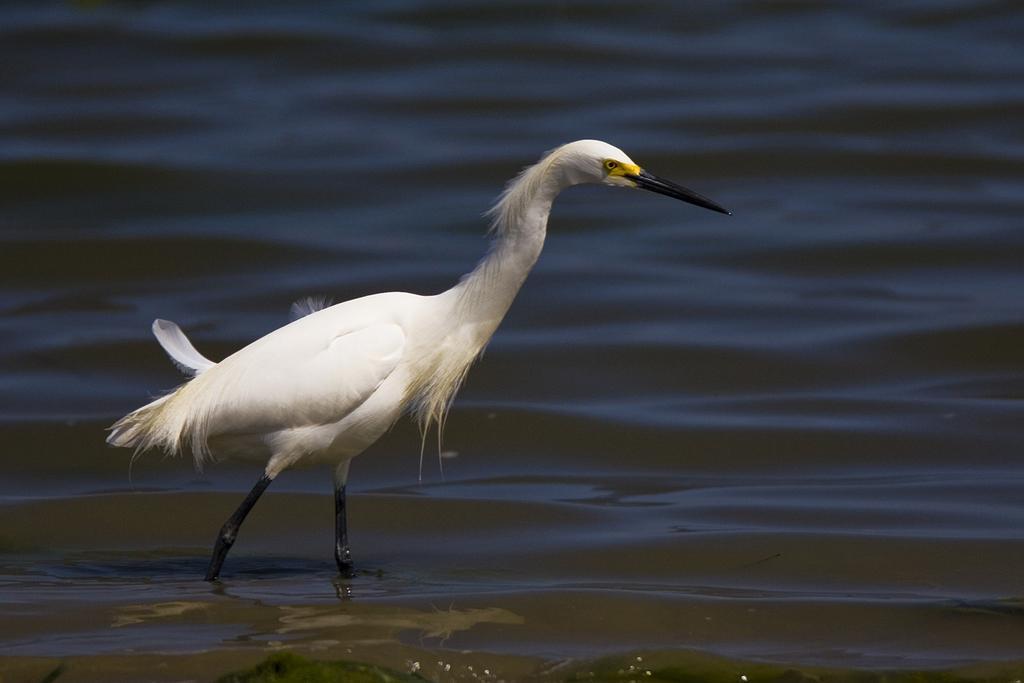In one or two sentences, can you explain what this image depicts? In this image there is a duck on the water. 